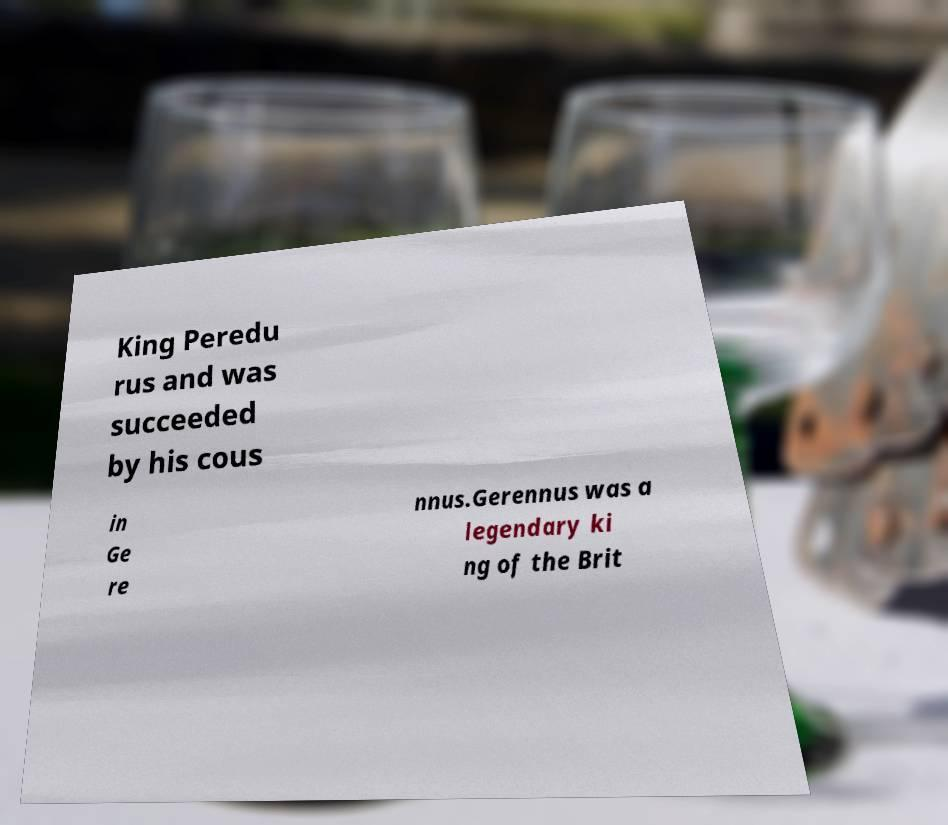Can you accurately transcribe the text from the provided image for me? King Peredu rus and was succeeded by his cous in Ge re nnus.Gerennus was a legendary ki ng of the Brit 